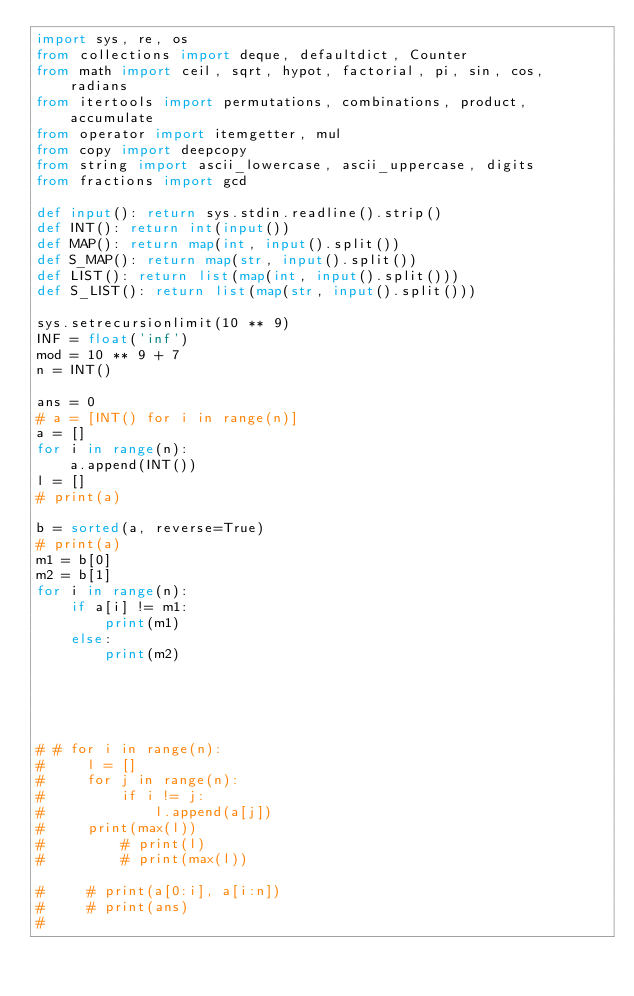<code> <loc_0><loc_0><loc_500><loc_500><_Python_>import sys, re, os
from collections import deque, defaultdict, Counter
from math import ceil, sqrt, hypot, factorial, pi, sin, cos, radians
from itertools import permutations, combinations, product, accumulate
from operator import itemgetter, mul
from copy import deepcopy
from string import ascii_lowercase, ascii_uppercase, digits
from fractions import gcd
 
def input(): return sys.stdin.readline().strip()
def INT(): return int(input())
def MAP(): return map(int, input().split())
def S_MAP(): return map(str, input().split())
def LIST(): return list(map(int, input().split()))
def S_LIST(): return list(map(str, input().split()))

sys.setrecursionlimit(10 ** 9)
INF = float('inf')
mod = 10 ** 9 + 7
n = INT()

ans = 0
# a = [INT() for i in range(n)]
a = []
for i in range(n):
    a.append(INT())
l = []
# print(a)

b = sorted(a, reverse=True)
# print(a)
m1 = b[0]
m2 = b[1]
for i in range(n):
    if a[i] != m1:
        print(m1)
    else:
        print(m2)
     




# # for i in range(n):
#     l = []
#     for j in range(n):
#         if i != j:
#             l.append(a[j])
#     print(max(l))
#         # print(l)
#         # print(max(l))

#     # print(a[0:i], a[i:n])
#     # print(ans)
# 
</code> 